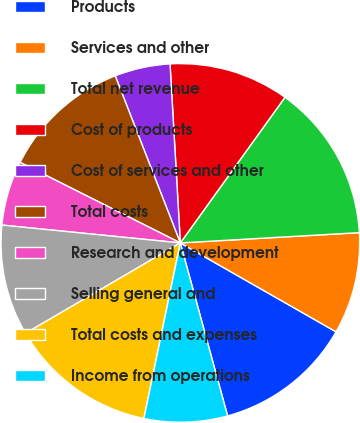Convert chart to OTSL. <chart><loc_0><loc_0><loc_500><loc_500><pie_chart><fcel>Products<fcel>Services and other<fcel>Total net revenue<fcel>Cost of products<fcel>Cost of services and other<fcel>Total costs<fcel>Research and development<fcel>Selling general and<fcel>Total costs and expenses<fcel>Income from operations<nl><fcel>12.5%<fcel>9.17%<fcel>14.17%<fcel>10.83%<fcel>5.0%<fcel>11.67%<fcel>5.83%<fcel>10.0%<fcel>13.33%<fcel>7.5%<nl></chart> 